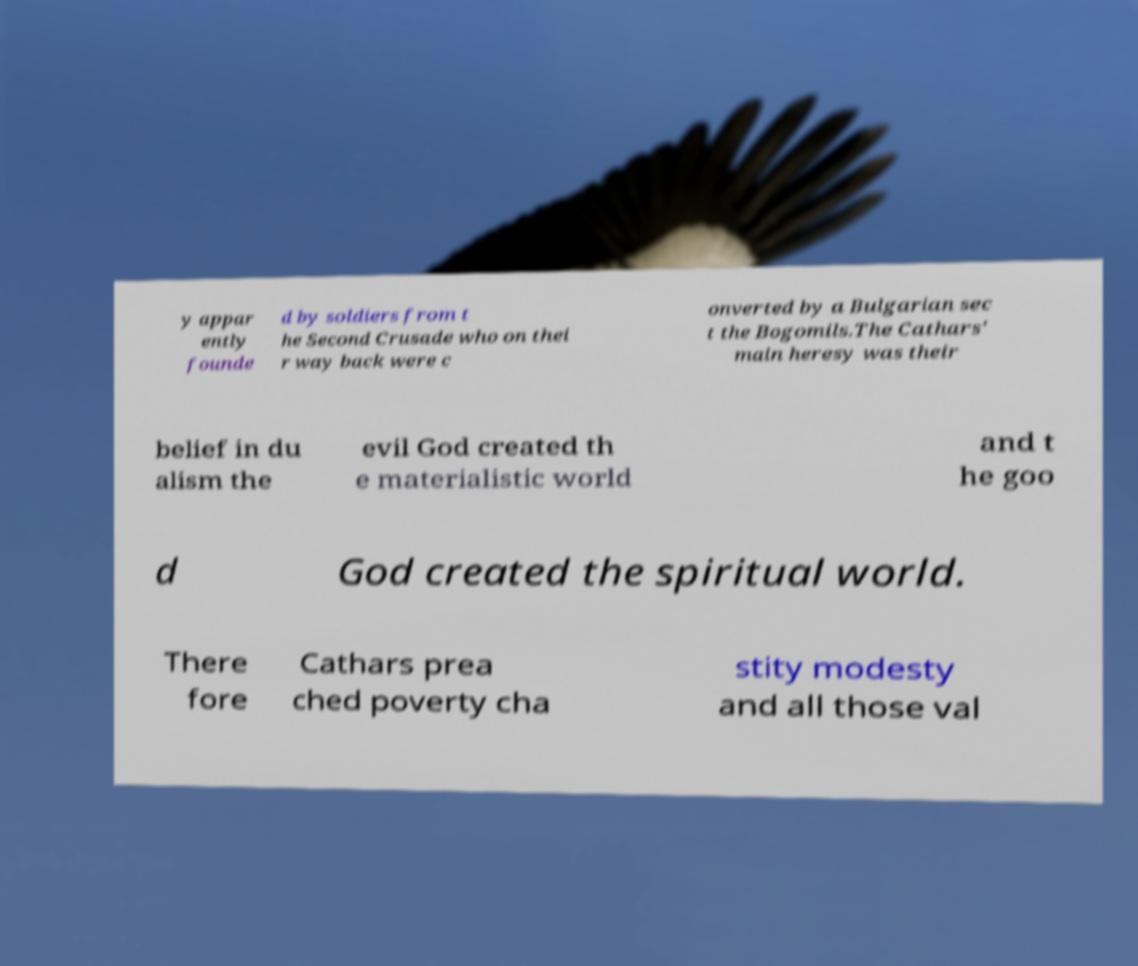Could you assist in decoding the text presented in this image and type it out clearly? y appar ently founde d by soldiers from t he Second Crusade who on thei r way back were c onverted by a Bulgarian sec t the Bogomils.The Cathars' main heresy was their belief in du alism the evil God created th e materialistic world and t he goo d God created the spiritual world. There fore Cathars prea ched poverty cha stity modesty and all those val 